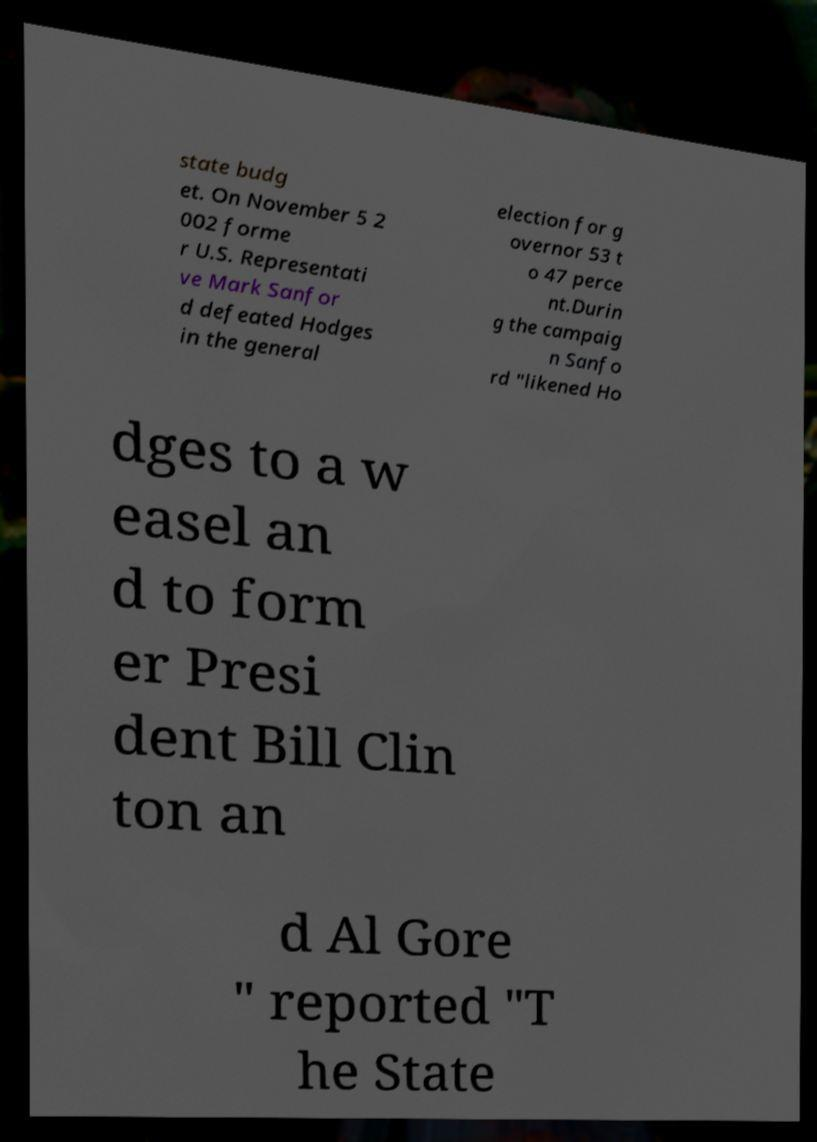Please read and relay the text visible in this image. What does it say? state budg et. On November 5 2 002 forme r U.S. Representati ve Mark Sanfor d defeated Hodges in the general election for g overnor 53 t o 47 perce nt.Durin g the campaig n Sanfo rd "likened Ho dges to a w easel an d to form er Presi dent Bill Clin ton an d Al Gore " reported "T he State 